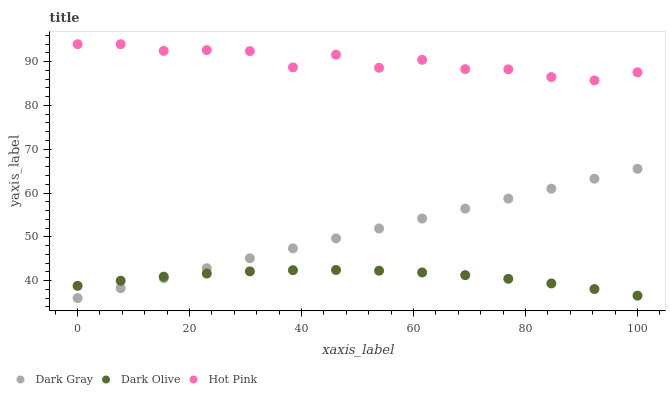Does Dark Olive have the minimum area under the curve?
Answer yes or no. Yes. Does Hot Pink have the maximum area under the curve?
Answer yes or no. Yes. Does Hot Pink have the minimum area under the curve?
Answer yes or no. No. Does Dark Olive have the maximum area under the curve?
Answer yes or no. No. Is Dark Gray the smoothest?
Answer yes or no. Yes. Is Hot Pink the roughest?
Answer yes or no. Yes. Is Dark Olive the smoothest?
Answer yes or no. No. Is Dark Olive the roughest?
Answer yes or no. No. Does Dark Gray have the lowest value?
Answer yes or no. Yes. Does Dark Olive have the lowest value?
Answer yes or no. No. Does Hot Pink have the highest value?
Answer yes or no. Yes. Does Dark Olive have the highest value?
Answer yes or no. No. Is Dark Gray less than Hot Pink?
Answer yes or no. Yes. Is Hot Pink greater than Dark Olive?
Answer yes or no. Yes. Does Dark Gray intersect Dark Olive?
Answer yes or no. Yes. Is Dark Gray less than Dark Olive?
Answer yes or no. No. Is Dark Gray greater than Dark Olive?
Answer yes or no. No. Does Dark Gray intersect Hot Pink?
Answer yes or no. No. 